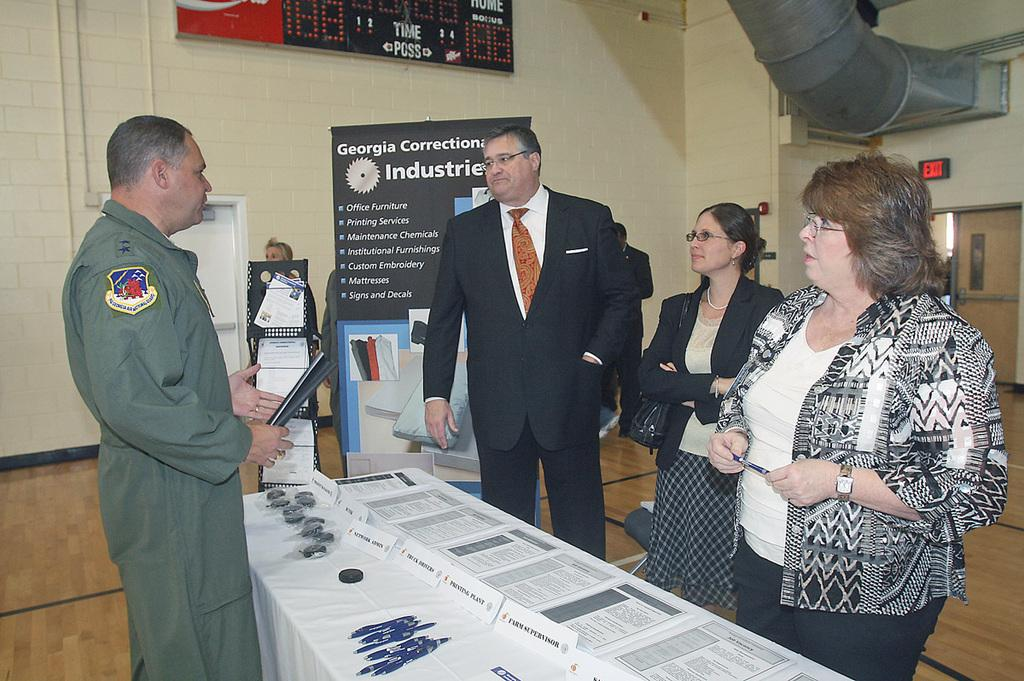How many people are in the image? There are four people in the image, two men and two women. What are the people doing in the image? The people are standing near a table. What items can be seen on the table? There are papers and pens on the table. What can be seen in the background of the image? There are posters and a wall in the background. How many sheep are visible in the image? There are no sheep present in the image. What color is the rub on the table? There is no rub present in the image. 